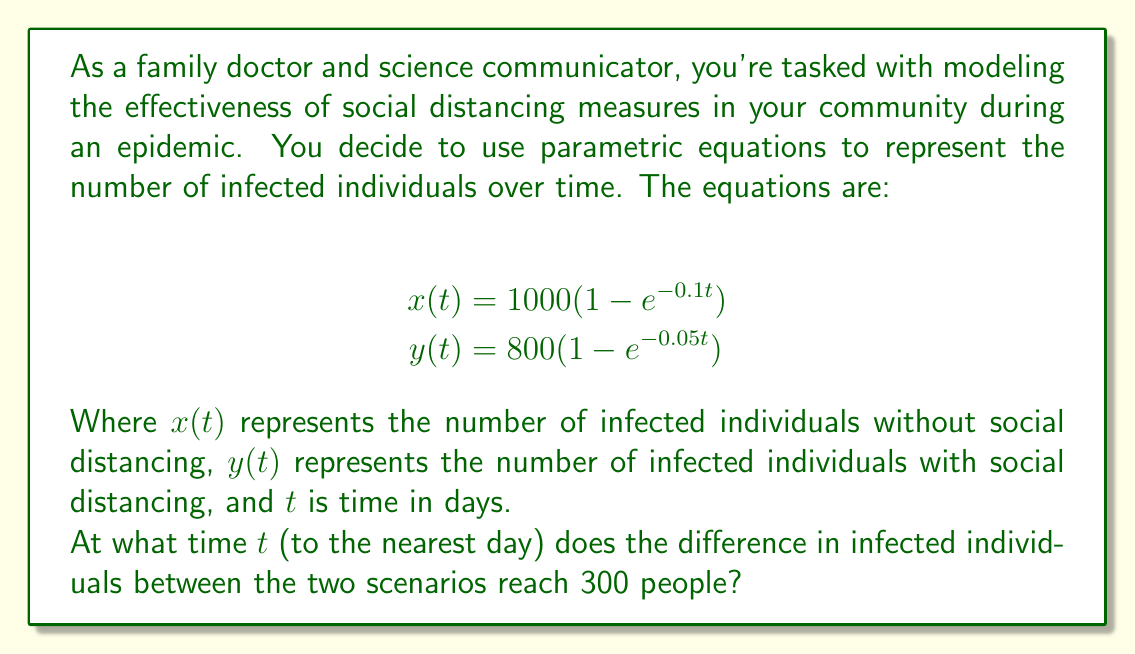Can you solve this math problem? To solve this problem, we need to follow these steps:

1) The difference in infected individuals is represented by $x(t) - y(t)$. We need to find $t$ when this difference equals 300.

2) Set up the equation:
   $x(t) - y(t) = 300$

3) Substitute the given functions:
   $1000(1 - e^{-0.1t}) - 800(1 - e^{-0.05t}) = 300$

4) Simplify:
   $1000 - 1000e^{-0.1t} - 800 + 800e^{-0.05t} = 300$
   $200 - 1000e^{-0.1t} + 800e^{-0.05t} = 300$
   $-1000e^{-0.1t} + 800e^{-0.05t} = 100$

5) This equation cannot be solved algebraically. We need to use numerical methods or graphing to find the solution.

6) Using a graphing calculator or computer software, we can plot the function:
   $f(t) = -1000e^{-0.1t} + 800e^{-0.05t} - 100$

7) Find the root of this function (where it crosses the x-axis).

8) The solution is approximately $t = 14.3$ days.

9) Rounding to the nearest day, we get 14 days.

This solution can be verified by plugging $t = 14$ back into the original equations:

$x(14) \approx 753$
$y(14) \approx 452$
$753 - 452 = 301$, which is very close to 300.
Answer: 14 days 